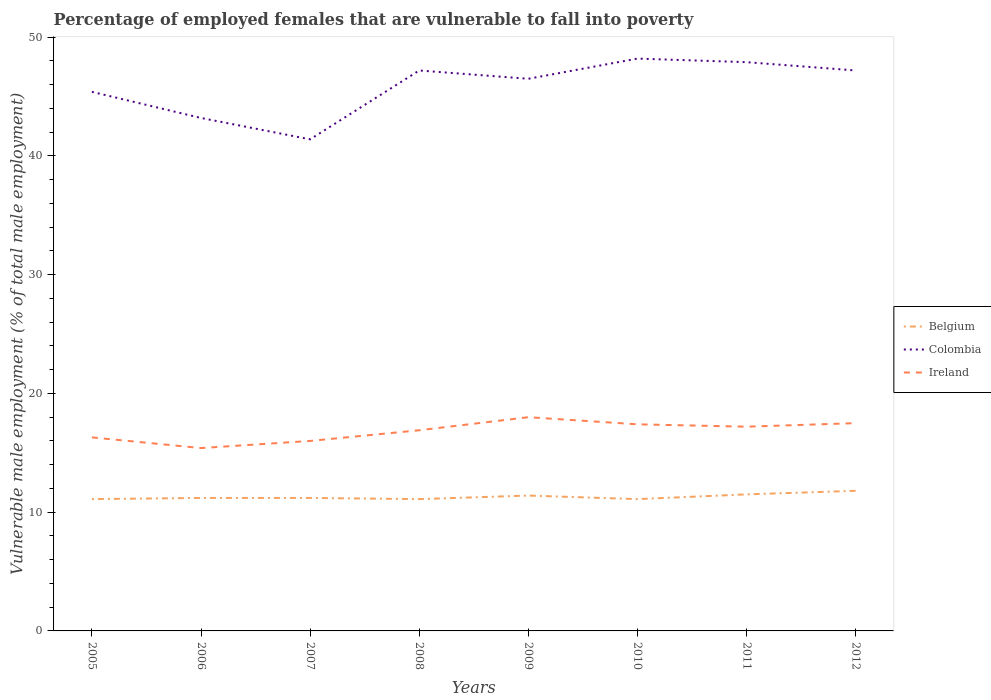Does the line corresponding to Colombia intersect with the line corresponding to Ireland?
Your response must be concise. No. Is the number of lines equal to the number of legend labels?
Keep it short and to the point. Yes. Across all years, what is the maximum percentage of employed females who are vulnerable to fall into poverty in Ireland?
Your answer should be compact. 15.4. In which year was the percentage of employed females who are vulnerable to fall into poverty in Belgium maximum?
Ensure brevity in your answer.  2005. What is the total percentage of employed females who are vulnerable to fall into poverty in Colombia in the graph?
Your response must be concise. -0.7. What is the difference between the highest and the second highest percentage of employed females who are vulnerable to fall into poverty in Colombia?
Provide a short and direct response. 6.8. What is the difference between the highest and the lowest percentage of employed females who are vulnerable to fall into poverty in Ireland?
Your answer should be compact. 5. How many years are there in the graph?
Offer a very short reply. 8. What is the difference between two consecutive major ticks on the Y-axis?
Provide a succinct answer. 10. Are the values on the major ticks of Y-axis written in scientific E-notation?
Keep it short and to the point. No. Where does the legend appear in the graph?
Provide a short and direct response. Center right. What is the title of the graph?
Your response must be concise. Percentage of employed females that are vulnerable to fall into poverty. Does "Russian Federation" appear as one of the legend labels in the graph?
Keep it short and to the point. No. What is the label or title of the X-axis?
Your answer should be very brief. Years. What is the label or title of the Y-axis?
Your answer should be very brief. Vulnerable male employment (% of total male employment). What is the Vulnerable male employment (% of total male employment) of Belgium in 2005?
Your response must be concise. 11.1. What is the Vulnerable male employment (% of total male employment) of Colombia in 2005?
Keep it short and to the point. 45.4. What is the Vulnerable male employment (% of total male employment) of Ireland in 2005?
Offer a very short reply. 16.3. What is the Vulnerable male employment (% of total male employment) of Belgium in 2006?
Offer a terse response. 11.2. What is the Vulnerable male employment (% of total male employment) of Colombia in 2006?
Your answer should be very brief. 43.2. What is the Vulnerable male employment (% of total male employment) in Ireland in 2006?
Offer a terse response. 15.4. What is the Vulnerable male employment (% of total male employment) in Belgium in 2007?
Your answer should be very brief. 11.2. What is the Vulnerable male employment (% of total male employment) of Colombia in 2007?
Your answer should be compact. 41.4. What is the Vulnerable male employment (% of total male employment) in Ireland in 2007?
Provide a short and direct response. 16. What is the Vulnerable male employment (% of total male employment) in Belgium in 2008?
Provide a short and direct response. 11.1. What is the Vulnerable male employment (% of total male employment) in Colombia in 2008?
Offer a terse response. 47.2. What is the Vulnerable male employment (% of total male employment) in Ireland in 2008?
Provide a succinct answer. 16.9. What is the Vulnerable male employment (% of total male employment) of Belgium in 2009?
Your answer should be very brief. 11.4. What is the Vulnerable male employment (% of total male employment) in Colombia in 2009?
Give a very brief answer. 46.5. What is the Vulnerable male employment (% of total male employment) of Belgium in 2010?
Ensure brevity in your answer.  11.1. What is the Vulnerable male employment (% of total male employment) of Colombia in 2010?
Keep it short and to the point. 48.2. What is the Vulnerable male employment (% of total male employment) of Ireland in 2010?
Provide a short and direct response. 17.4. What is the Vulnerable male employment (% of total male employment) of Belgium in 2011?
Make the answer very short. 11.5. What is the Vulnerable male employment (% of total male employment) of Colombia in 2011?
Your response must be concise. 47.9. What is the Vulnerable male employment (% of total male employment) of Ireland in 2011?
Provide a short and direct response. 17.2. What is the Vulnerable male employment (% of total male employment) in Belgium in 2012?
Provide a succinct answer. 11.8. What is the Vulnerable male employment (% of total male employment) of Colombia in 2012?
Provide a short and direct response. 47.2. What is the Vulnerable male employment (% of total male employment) of Ireland in 2012?
Your answer should be compact. 17.5. Across all years, what is the maximum Vulnerable male employment (% of total male employment) in Belgium?
Ensure brevity in your answer.  11.8. Across all years, what is the maximum Vulnerable male employment (% of total male employment) in Colombia?
Your answer should be compact. 48.2. Across all years, what is the maximum Vulnerable male employment (% of total male employment) in Ireland?
Provide a short and direct response. 18. Across all years, what is the minimum Vulnerable male employment (% of total male employment) in Belgium?
Your answer should be very brief. 11.1. Across all years, what is the minimum Vulnerable male employment (% of total male employment) of Colombia?
Offer a very short reply. 41.4. Across all years, what is the minimum Vulnerable male employment (% of total male employment) of Ireland?
Provide a succinct answer. 15.4. What is the total Vulnerable male employment (% of total male employment) in Belgium in the graph?
Give a very brief answer. 90.4. What is the total Vulnerable male employment (% of total male employment) of Colombia in the graph?
Give a very brief answer. 367. What is the total Vulnerable male employment (% of total male employment) of Ireland in the graph?
Your answer should be compact. 134.7. What is the difference between the Vulnerable male employment (% of total male employment) in Belgium in 2005 and that in 2006?
Provide a short and direct response. -0.1. What is the difference between the Vulnerable male employment (% of total male employment) in Colombia in 2005 and that in 2006?
Your answer should be very brief. 2.2. What is the difference between the Vulnerable male employment (% of total male employment) in Belgium in 2005 and that in 2007?
Offer a very short reply. -0.1. What is the difference between the Vulnerable male employment (% of total male employment) of Colombia in 2005 and that in 2007?
Keep it short and to the point. 4. What is the difference between the Vulnerable male employment (% of total male employment) of Belgium in 2005 and that in 2008?
Make the answer very short. 0. What is the difference between the Vulnerable male employment (% of total male employment) in Colombia in 2005 and that in 2008?
Offer a very short reply. -1.8. What is the difference between the Vulnerable male employment (% of total male employment) of Belgium in 2005 and that in 2009?
Offer a very short reply. -0.3. What is the difference between the Vulnerable male employment (% of total male employment) of Colombia in 2005 and that in 2009?
Your response must be concise. -1.1. What is the difference between the Vulnerable male employment (% of total male employment) in Colombia in 2005 and that in 2010?
Offer a terse response. -2.8. What is the difference between the Vulnerable male employment (% of total male employment) of Belgium in 2005 and that in 2011?
Keep it short and to the point. -0.4. What is the difference between the Vulnerable male employment (% of total male employment) of Colombia in 2005 and that in 2011?
Offer a terse response. -2.5. What is the difference between the Vulnerable male employment (% of total male employment) in Ireland in 2005 and that in 2011?
Your response must be concise. -0.9. What is the difference between the Vulnerable male employment (% of total male employment) in Ireland in 2005 and that in 2012?
Your answer should be compact. -1.2. What is the difference between the Vulnerable male employment (% of total male employment) of Belgium in 2006 and that in 2007?
Provide a short and direct response. 0. What is the difference between the Vulnerable male employment (% of total male employment) in Colombia in 2006 and that in 2007?
Your answer should be compact. 1.8. What is the difference between the Vulnerable male employment (% of total male employment) in Ireland in 2006 and that in 2007?
Your response must be concise. -0.6. What is the difference between the Vulnerable male employment (% of total male employment) of Colombia in 2006 and that in 2008?
Give a very brief answer. -4. What is the difference between the Vulnerable male employment (% of total male employment) in Ireland in 2006 and that in 2008?
Make the answer very short. -1.5. What is the difference between the Vulnerable male employment (% of total male employment) of Belgium in 2006 and that in 2009?
Keep it short and to the point. -0.2. What is the difference between the Vulnerable male employment (% of total male employment) in Colombia in 2006 and that in 2009?
Ensure brevity in your answer.  -3.3. What is the difference between the Vulnerable male employment (% of total male employment) of Belgium in 2006 and that in 2010?
Provide a succinct answer. 0.1. What is the difference between the Vulnerable male employment (% of total male employment) of Ireland in 2006 and that in 2011?
Your response must be concise. -1.8. What is the difference between the Vulnerable male employment (% of total male employment) in Colombia in 2006 and that in 2012?
Ensure brevity in your answer.  -4. What is the difference between the Vulnerable male employment (% of total male employment) in Ireland in 2006 and that in 2012?
Give a very brief answer. -2.1. What is the difference between the Vulnerable male employment (% of total male employment) of Belgium in 2007 and that in 2008?
Provide a short and direct response. 0.1. What is the difference between the Vulnerable male employment (% of total male employment) of Ireland in 2007 and that in 2008?
Your answer should be compact. -0.9. What is the difference between the Vulnerable male employment (% of total male employment) of Belgium in 2007 and that in 2009?
Your response must be concise. -0.2. What is the difference between the Vulnerable male employment (% of total male employment) in Colombia in 2007 and that in 2010?
Make the answer very short. -6.8. What is the difference between the Vulnerable male employment (% of total male employment) of Ireland in 2007 and that in 2010?
Provide a succinct answer. -1.4. What is the difference between the Vulnerable male employment (% of total male employment) of Belgium in 2007 and that in 2011?
Keep it short and to the point. -0.3. What is the difference between the Vulnerable male employment (% of total male employment) of Colombia in 2007 and that in 2011?
Make the answer very short. -6.5. What is the difference between the Vulnerable male employment (% of total male employment) in Belgium in 2007 and that in 2012?
Your response must be concise. -0.6. What is the difference between the Vulnerable male employment (% of total male employment) of Ireland in 2007 and that in 2012?
Your answer should be compact. -1.5. What is the difference between the Vulnerable male employment (% of total male employment) in Belgium in 2008 and that in 2009?
Provide a succinct answer. -0.3. What is the difference between the Vulnerable male employment (% of total male employment) in Ireland in 2008 and that in 2010?
Make the answer very short. -0.5. What is the difference between the Vulnerable male employment (% of total male employment) of Belgium in 2008 and that in 2011?
Ensure brevity in your answer.  -0.4. What is the difference between the Vulnerable male employment (% of total male employment) of Belgium in 2008 and that in 2012?
Give a very brief answer. -0.7. What is the difference between the Vulnerable male employment (% of total male employment) in Ireland in 2008 and that in 2012?
Offer a terse response. -0.6. What is the difference between the Vulnerable male employment (% of total male employment) of Belgium in 2009 and that in 2010?
Provide a succinct answer. 0.3. What is the difference between the Vulnerable male employment (% of total male employment) in Colombia in 2009 and that in 2010?
Your answer should be very brief. -1.7. What is the difference between the Vulnerable male employment (% of total male employment) of Belgium in 2009 and that in 2011?
Provide a short and direct response. -0.1. What is the difference between the Vulnerable male employment (% of total male employment) of Belgium in 2009 and that in 2012?
Keep it short and to the point. -0.4. What is the difference between the Vulnerable male employment (% of total male employment) of Colombia in 2009 and that in 2012?
Your answer should be very brief. -0.7. What is the difference between the Vulnerable male employment (% of total male employment) of Colombia in 2010 and that in 2011?
Ensure brevity in your answer.  0.3. What is the difference between the Vulnerable male employment (% of total male employment) in Colombia in 2010 and that in 2012?
Your answer should be compact. 1. What is the difference between the Vulnerable male employment (% of total male employment) of Ireland in 2010 and that in 2012?
Your answer should be compact. -0.1. What is the difference between the Vulnerable male employment (% of total male employment) of Ireland in 2011 and that in 2012?
Offer a terse response. -0.3. What is the difference between the Vulnerable male employment (% of total male employment) of Belgium in 2005 and the Vulnerable male employment (% of total male employment) of Colombia in 2006?
Offer a very short reply. -32.1. What is the difference between the Vulnerable male employment (% of total male employment) of Belgium in 2005 and the Vulnerable male employment (% of total male employment) of Colombia in 2007?
Give a very brief answer. -30.3. What is the difference between the Vulnerable male employment (% of total male employment) in Belgium in 2005 and the Vulnerable male employment (% of total male employment) in Ireland in 2007?
Give a very brief answer. -4.9. What is the difference between the Vulnerable male employment (% of total male employment) of Colombia in 2005 and the Vulnerable male employment (% of total male employment) of Ireland in 2007?
Your answer should be very brief. 29.4. What is the difference between the Vulnerable male employment (% of total male employment) in Belgium in 2005 and the Vulnerable male employment (% of total male employment) in Colombia in 2008?
Keep it short and to the point. -36.1. What is the difference between the Vulnerable male employment (% of total male employment) of Belgium in 2005 and the Vulnerable male employment (% of total male employment) of Ireland in 2008?
Your response must be concise. -5.8. What is the difference between the Vulnerable male employment (% of total male employment) in Colombia in 2005 and the Vulnerable male employment (% of total male employment) in Ireland in 2008?
Give a very brief answer. 28.5. What is the difference between the Vulnerable male employment (% of total male employment) of Belgium in 2005 and the Vulnerable male employment (% of total male employment) of Colombia in 2009?
Offer a very short reply. -35.4. What is the difference between the Vulnerable male employment (% of total male employment) in Belgium in 2005 and the Vulnerable male employment (% of total male employment) in Ireland in 2009?
Give a very brief answer. -6.9. What is the difference between the Vulnerable male employment (% of total male employment) in Colombia in 2005 and the Vulnerable male employment (% of total male employment) in Ireland in 2009?
Provide a short and direct response. 27.4. What is the difference between the Vulnerable male employment (% of total male employment) in Belgium in 2005 and the Vulnerable male employment (% of total male employment) in Colombia in 2010?
Provide a succinct answer. -37.1. What is the difference between the Vulnerable male employment (% of total male employment) in Belgium in 2005 and the Vulnerable male employment (% of total male employment) in Ireland in 2010?
Ensure brevity in your answer.  -6.3. What is the difference between the Vulnerable male employment (% of total male employment) in Belgium in 2005 and the Vulnerable male employment (% of total male employment) in Colombia in 2011?
Your response must be concise. -36.8. What is the difference between the Vulnerable male employment (% of total male employment) of Colombia in 2005 and the Vulnerable male employment (% of total male employment) of Ireland in 2011?
Provide a succinct answer. 28.2. What is the difference between the Vulnerable male employment (% of total male employment) of Belgium in 2005 and the Vulnerable male employment (% of total male employment) of Colombia in 2012?
Keep it short and to the point. -36.1. What is the difference between the Vulnerable male employment (% of total male employment) of Belgium in 2005 and the Vulnerable male employment (% of total male employment) of Ireland in 2012?
Your answer should be compact. -6.4. What is the difference between the Vulnerable male employment (% of total male employment) in Colombia in 2005 and the Vulnerable male employment (% of total male employment) in Ireland in 2012?
Your answer should be very brief. 27.9. What is the difference between the Vulnerable male employment (% of total male employment) of Belgium in 2006 and the Vulnerable male employment (% of total male employment) of Colombia in 2007?
Keep it short and to the point. -30.2. What is the difference between the Vulnerable male employment (% of total male employment) in Belgium in 2006 and the Vulnerable male employment (% of total male employment) in Ireland in 2007?
Provide a short and direct response. -4.8. What is the difference between the Vulnerable male employment (% of total male employment) of Colombia in 2006 and the Vulnerable male employment (% of total male employment) of Ireland in 2007?
Your response must be concise. 27.2. What is the difference between the Vulnerable male employment (% of total male employment) in Belgium in 2006 and the Vulnerable male employment (% of total male employment) in Colombia in 2008?
Your answer should be very brief. -36. What is the difference between the Vulnerable male employment (% of total male employment) of Colombia in 2006 and the Vulnerable male employment (% of total male employment) of Ireland in 2008?
Your answer should be very brief. 26.3. What is the difference between the Vulnerable male employment (% of total male employment) of Belgium in 2006 and the Vulnerable male employment (% of total male employment) of Colombia in 2009?
Offer a terse response. -35.3. What is the difference between the Vulnerable male employment (% of total male employment) in Belgium in 2006 and the Vulnerable male employment (% of total male employment) in Ireland in 2009?
Your answer should be compact. -6.8. What is the difference between the Vulnerable male employment (% of total male employment) of Colombia in 2006 and the Vulnerable male employment (% of total male employment) of Ireland in 2009?
Your answer should be very brief. 25.2. What is the difference between the Vulnerable male employment (% of total male employment) in Belgium in 2006 and the Vulnerable male employment (% of total male employment) in Colombia in 2010?
Offer a very short reply. -37. What is the difference between the Vulnerable male employment (% of total male employment) in Colombia in 2006 and the Vulnerable male employment (% of total male employment) in Ireland in 2010?
Your response must be concise. 25.8. What is the difference between the Vulnerable male employment (% of total male employment) of Belgium in 2006 and the Vulnerable male employment (% of total male employment) of Colombia in 2011?
Provide a succinct answer. -36.7. What is the difference between the Vulnerable male employment (% of total male employment) in Belgium in 2006 and the Vulnerable male employment (% of total male employment) in Colombia in 2012?
Offer a terse response. -36. What is the difference between the Vulnerable male employment (% of total male employment) of Colombia in 2006 and the Vulnerable male employment (% of total male employment) of Ireland in 2012?
Give a very brief answer. 25.7. What is the difference between the Vulnerable male employment (% of total male employment) of Belgium in 2007 and the Vulnerable male employment (% of total male employment) of Colombia in 2008?
Offer a very short reply. -36. What is the difference between the Vulnerable male employment (% of total male employment) in Belgium in 2007 and the Vulnerable male employment (% of total male employment) in Ireland in 2008?
Your response must be concise. -5.7. What is the difference between the Vulnerable male employment (% of total male employment) in Colombia in 2007 and the Vulnerable male employment (% of total male employment) in Ireland in 2008?
Make the answer very short. 24.5. What is the difference between the Vulnerable male employment (% of total male employment) of Belgium in 2007 and the Vulnerable male employment (% of total male employment) of Colombia in 2009?
Provide a succinct answer. -35.3. What is the difference between the Vulnerable male employment (% of total male employment) of Colombia in 2007 and the Vulnerable male employment (% of total male employment) of Ireland in 2009?
Your answer should be very brief. 23.4. What is the difference between the Vulnerable male employment (% of total male employment) of Belgium in 2007 and the Vulnerable male employment (% of total male employment) of Colombia in 2010?
Your response must be concise. -37. What is the difference between the Vulnerable male employment (% of total male employment) in Belgium in 2007 and the Vulnerable male employment (% of total male employment) in Ireland in 2010?
Provide a short and direct response. -6.2. What is the difference between the Vulnerable male employment (% of total male employment) of Colombia in 2007 and the Vulnerable male employment (% of total male employment) of Ireland in 2010?
Make the answer very short. 24. What is the difference between the Vulnerable male employment (% of total male employment) of Belgium in 2007 and the Vulnerable male employment (% of total male employment) of Colombia in 2011?
Give a very brief answer. -36.7. What is the difference between the Vulnerable male employment (% of total male employment) in Belgium in 2007 and the Vulnerable male employment (% of total male employment) in Ireland in 2011?
Keep it short and to the point. -6. What is the difference between the Vulnerable male employment (% of total male employment) of Colombia in 2007 and the Vulnerable male employment (% of total male employment) of Ireland in 2011?
Offer a terse response. 24.2. What is the difference between the Vulnerable male employment (% of total male employment) of Belgium in 2007 and the Vulnerable male employment (% of total male employment) of Colombia in 2012?
Give a very brief answer. -36. What is the difference between the Vulnerable male employment (% of total male employment) in Belgium in 2007 and the Vulnerable male employment (% of total male employment) in Ireland in 2012?
Provide a succinct answer. -6.3. What is the difference between the Vulnerable male employment (% of total male employment) of Colombia in 2007 and the Vulnerable male employment (% of total male employment) of Ireland in 2012?
Your answer should be very brief. 23.9. What is the difference between the Vulnerable male employment (% of total male employment) of Belgium in 2008 and the Vulnerable male employment (% of total male employment) of Colombia in 2009?
Make the answer very short. -35.4. What is the difference between the Vulnerable male employment (% of total male employment) in Colombia in 2008 and the Vulnerable male employment (% of total male employment) in Ireland in 2009?
Keep it short and to the point. 29.2. What is the difference between the Vulnerable male employment (% of total male employment) of Belgium in 2008 and the Vulnerable male employment (% of total male employment) of Colombia in 2010?
Your answer should be compact. -37.1. What is the difference between the Vulnerable male employment (% of total male employment) of Belgium in 2008 and the Vulnerable male employment (% of total male employment) of Ireland in 2010?
Your response must be concise. -6.3. What is the difference between the Vulnerable male employment (% of total male employment) in Colombia in 2008 and the Vulnerable male employment (% of total male employment) in Ireland in 2010?
Give a very brief answer. 29.8. What is the difference between the Vulnerable male employment (% of total male employment) in Belgium in 2008 and the Vulnerable male employment (% of total male employment) in Colombia in 2011?
Provide a succinct answer. -36.8. What is the difference between the Vulnerable male employment (% of total male employment) of Colombia in 2008 and the Vulnerable male employment (% of total male employment) of Ireland in 2011?
Your answer should be very brief. 30. What is the difference between the Vulnerable male employment (% of total male employment) in Belgium in 2008 and the Vulnerable male employment (% of total male employment) in Colombia in 2012?
Your response must be concise. -36.1. What is the difference between the Vulnerable male employment (% of total male employment) in Colombia in 2008 and the Vulnerable male employment (% of total male employment) in Ireland in 2012?
Offer a terse response. 29.7. What is the difference between the Vulnerable male employment (% of total male employment) in Belgium in 2009 and the Vulnerable male employment (% of total male employment) in Colombia in 2010?
Give a very brief answer. -36.8. What is the difference between the Vulnerable male employment (% of total male employment) of Belgium in 2009 and the Vulnerable male employment (% of total male employment) of Ireland in 2010?
Make the answer very short. -6. What is the difference between the Vulnerable male employment (% of total male employment) in Colombia in 2009 and the Vulnerable male employment (% of total male employment) in Ireland in 2010?
Offer a very short reply. 29.1. What is the difference between the Vulnerable male employment (% of total male employment) in Belgium in 2009 and the Vulnerable male employment (% of total male employment) in Colombia in 2011?
Your response must be concise. -36.5. What is the difference between the Vulnerable male employment (% of total male employment) in Colombia in 2009 and the Vulnerable male employment (% of total male employment) in Ireland in 2011?
Your answer should be compact. 29.3. What is the difference between the Vulnerable male employment (% of total male employment) of Belgium in 2009 and the Vulnerable male employment (% of total male employment) of Colombia in 2012?
Provide a short and direct response. -35.8. What is the difference between the Vulnerable male employment (% of total male employment) of Belgium in 2009 and the Vulnerable male employment (% of total male employment) of Ireland in 2012?
Your response must be concise. -6.1. What is the difference between the Vulnerable male employment (% of total male employment) of Colombia in 2009 and the Vulnerable male employment (% of total male employment) of Ireland in 2012?
Your response must be concise. 29. What is the difference between the Vulnerable male employment (% of total male employment) of Belgium in 2010 and the Vulnerable male employment (% of total male employment) of Colombia in 2011?
Your response must be concise. -36.8. What is the difference between the Vulnerable male employment (% of total male employment) of Colombia in 2010 and the Vulnerable male employment (% of total male employment) of Ireland in 2011?
Your answer should be very brief. 31. What is the difference between the Vulnerable male employment (% of total male employment) of Belgium in 2010 and the Vulnerable male employment (% of total male employment) of Colombia in 2012?
Make the answer very short. -36.1. What is the difference between the Vulnerable male employment (% of total male employment) of Belgium in 2010 and the Vulnerable male employment (% of total male employment) of Ireland in 2012?
Provide a short and direct response. -6.4. What is the difference between the Vulnerable male employment (% of total male employment) in Colombia in 2010 and the Vulnerable male employment (% of total male employment) in Ireland in 2012?
Offer a very short reply. 30.7. What is the difference between the Vulnerable male employment (% of total male employment) in Belgium in 2011 and the Vulnerable male employment (% of total male employment) in Colombia in 2012?
Provide a short and direct response. -35.7. What is the difference between the Vulnerable male employment (% of total male employment) of Colombia in 2011 and the Vulnerable male employment (% of total male employment) of Ireland in 2012?
Offer a terse response. 30.4. What is the average Vulnerable male employment (% of total male employment) in Belgium per year?
Give a very brief answer. 11.3. What is the average Vulnerable male employment (% of total male employment) of Colombia per year?
Provide a short and direct response. 45.88. What is the average Vulnerable male employment (% of total male employment) of Ireland per year?
Give a very brief answer. 16.84. In the year 2005, what is the difference between the Vulnerable male employment (% of total male employment) of Belgium and Vulnerable male employment (% of total male employment) of Colombia?
Keep it short and to the point. -34.3. In the year 2005, what is the difference between the Vulnerable male employment (% of total male employment) in Belgium and Vulnerable male employment (% of total male employment) in Ireland?
Give a very brief answer. -5.2. In the year 2005, what is the difference between the Vulnerable male employment (% of total male employment) in Colombia and Vulnerable male employment (% of total male employment) in Ireland?
Ensure brevity in your answer.  29.1. In the year 2006, what is the difference between the Vulnerable male employment (% of total male employment) of Belgium and Vulnerable male employment (% of total male employment) of Colombia?
Provide a succinct answer. -32. In the year 2006, what is the difference between the Vulnerable male employment (% of total male employment) in Colombia and Vulnerable male employment (% of total male employment) in Ireland?
Provide a short and direct response. 27.8. In the year 2007, what is the difference between the Vulnerable male employment (% of total male employment) in Belgium and Vulnerable male employment (% of total male employment) in Colombia?
Your answer should be compact. -30.2. In the year 2007, what is the difference between the Vulnerable male employment (% of total male employment) of Colombia and Vulnerable male employment (% of total male employment) of Ireland?
Your response must be concise. 25.4. In the year 2008, what is the difference between the Vulnerable male employment (% of total male employment) of Belgium and Vulnerable male employment (% of total male employment) of Colombia?
Your response must be concise. -36.1. In the year 2008, what is the difference between the Vulnerable male employment (% of total male employment) of Belgium and Vulnerable male employment (% of total male employment) of Ireland?
Make the answer very short. -5.8. In the year 2008, what is the difference between the Vulnerable male employment (% of total male employment) of Colombia and Vulnerable male employment (% of total male employment) of Ireland?
Make the answer very short. 30.3. In the year 2009, what is the difference between the Vulnerable male employment (% of total male employment) in Belgium and Vulnerable male employment (% of total male employment) in Colombia?
Ensure brevity in your answer.  -35.1. In the year 2009, what is the difference between the Vulnerable male employment (% of total male employment) of Colombia and Vulnerable male employment (% of total male employment) of Ireland?
Provide a short and direct response. 28.5. In the year 2010, what is the difference between the Vulnerable male employment (% of total male employment) of Belgium and Vulnerable male employment (% of total male employment) of Colombia?
Your answer should be compact. -37.1. In the year 2010, what is the difference between the Vulnerable male employment (% of total male employment) in Belgium and Vulnerable male employment (% of total male employment) in Ireland?
Provide a succinct answer. -6.3. In the year 2010, what is the difference between the Vulnerable male employment (% of total male employment) of Colombia and Vulnerable male employment (% of total male employment) of Ireland?
Your answer should be very brief. 30.8. In the year 2011, what is the difference between the Vulnerable male employment (% of total male employment) in Belgium and Vulnerable male employment (% of total male employment) in Colombia?
Your answer should be very brief. -36.4. In the year 2011, what is the difference between the Vulnerable male employment (% of total male employment) of Belgium and Vulnerable male employment (% of total male employment) of Ireland?
Offer a very short reply. -5.7. In the year 2011, what is the difference between the Vulnerable male employment (% of total male employment) of Colombia and Vulnerable male employment (% of total male employment) of Ireland?
Keep it short and to the point. 30.7. In the year 2012, what is the difference between the Vulnerable male employment (% of total male employment) in Belgium and Vulnerable male employment (% of total male employment) in Colombia?
Your answer should be compact. -35.4. In the year 2012, what is the difference between the Vulnerable male employment (% of total male employment) in Colombia and Vulnerable male employment (% of total male employment) in Ireland?
Keep it short and to the point. 29.7. What is the ratio of the Vulnerable male employment (% of total male employment) of Colombia in 2005 to that in 2006?
Provide a short and direct response. 1.05. What is the ratio of the Vulnerable male employment (% of total male employment) in Ireland in 2005 to that in 2006?
Make the answer very short. 1.06. What is the ratio of the Vulnerable male employment (% of total male employment) in Belgium in 2005 to that in 2007?
Offer a very short reply. 0.99. What is the ratio of the Vulnerable male employment (% of total male employment) in Colombia in 2005 to that in 2007?
Your answer should be very brief. 1.1. What is the ratio of the Vulnerable male employment (% of total male employment) in Ireland in 2005 to that in 2007?
Your response must be concise. 1.02. What is the ratio of the Vulnerable male employment (% of total male employment) in Belgium in 2005 to that in 2008?
Provide a succinct answer. 1. What is the ratio of the Vulnerable male employment (% of total male employment) of Colombia in 2005 to that in 2008?
Your answer should be compact. 0.96. What is the ratio of the Vulnerable male employment (% of total male employment) of Ireland in 2005 to that in 2008?
Offer a terse response. 0.96. What is the ratio of the Vulnerable male employment (% of total male employment) of Belgium in 2005 to that in 2009?
Offer a very short reply. 0.97. What is the ratio of the Vulnerable male employment (% of total male employment) in Colombia in 2005 to that in 2009?
Make the answer very short. 0.98. What is the ratio of the Vulnerable male employment (% of total male employment) in Ireland in 2005 to that in 2009?
Offer a terse response. 0.91. What is the ratio of the Vulnerable male employment (% of total male employment) in Belgium in 2005 to that in 2010?
Provide a short and direct response. 1. What is the ratio of the Vulnerable male employment (% of total male employment) of Colombia in 2005 to that in 2010?
Your response must be concise. 0.94. What is the ratio of the Vulnerable male employment (% of total male employment) of Ireland in 2005 to that in 2010?
Your answer should be very brief. 0.94. What is the ratio of the Vulnerable male employment (% of total male employment) in Belgium in 2005 to that in 2011?
Make the answer very short. 0.97. What is the ratio of the Vulnerable male employment (% of total male employment) of Colombia in 2005 to that in 2011?
Give a very brief answer. 0.95. What is the ratio of the Vulnerable male employment (% of total male employment) in Ireland in 2005 to that in 2011?
Offer a terse response. 0.95. What is the ratio of the Vulnerable male employment (% of total male employment) of Belgium in 2005 to that in 2012?
Your answer should be compact. 0.94. What is the ratio of the Vulnerable male employment (% of total male employment) of Colombia in 2005 to that in 2012?
Your response must be concise. 0.96. What is the ratio of the Vulnerable male employment (% of total male employment) in Ireland in 2005 to that in 2012?
Provide a short and direct response. 0.93. What is the ratio of the Vulnerable male employment (% of total male employment) of Colombia in 2006 to that in 2007?
Make the answer very short. 1.04. What is the ratio of the Vulnerable male employment (% of total male employment) in Ireland in 2006 to that in 2007?
Ensure brevity in your answer.  0.96. What is the ratio of the Vulnerable male employment (% of total male employment) in Colombia in 2006 to that in 2008?
Provide a succinct answer. 0.92. What is the ratio of the Vulnerable male employment (% of total male employment) in Ireland in 2006 to that in 2008?
Give a very brief answer. 0.91. What is the ratio of the Vulnerable male employment (% of total male employment) of Belgium in 2006 to that in 2009?
Your response must be concise. 0.98. What is the ratio of the Vulnerable male employment (% of total male employment) of Colombia in 2006 to that in 2009?
Ensure brevity in your answer.  0.93. What is the ratio of the Vulnerable male employment (% of total male employment) of Ireland in 2006 to that in 2009?
Provide a short and direct response. 0.86. What is the ratio of the Vulnerable male employment (% of total male employment) of Belgium in 2006 to that in 2010?
Make the answer very short. 1.01. What is the ratio of the Vulnerable male employment (% of total male employment) of Colombia in 2006 to that in 2010?
Keep it short and to the point. 0.9. What is the ratio of the Vulnerable male employment (% of total male employment) of Ireland in 2006 to that in 2010?
Your response must be concise. 0.89. What is the ratio of the Vulnerable male employment (% of total male employment) in Belgium in 2006 to that in 2011?
Provide a short and direct response. 0.97. What is the ratio of the Vulnerable male employment (% of total male employment) of Colombia in 2006 to that in 2011?
Provide a succinct answer. 0.9. What is the ratio of the Vulnerable male employment (% of total male employment) in Ireland in 2006 to that in 2011?
Your answer should be very brief. 0.9. What is the ratio of the Vulnerable male employment (% of total male employment) in Belgium in 2006 to that in 2012?
Your response must be concise. 0.95. What is the ratio of the Vulnerable male employment (% of total male employment) of Colombia in 2006 to that in 2012?
Provide a short and direct response. 0.92. What is the ratio of the Vulnerable male employment (% of total male employment) in Belgium in 2007 to that in 2008?
Ensure brevity in your answer.  1.01. What is the ratio of the Vulnerable male employment (% of total male employment) in Colombia in 2007 to that in 2008?
Make the answer very short. 0.88. What is the ratio of the Vulnerable male employment (% of total male employment) of Ireland in 2007 to that in 2008?
Give a very brief answer. 0.95. What is the ratio of the Vulnerable male employment (% of total male employment) in Belgium in 2007 to that in 2009?
Give a very brief answer. 0.98. What is the ratio of the Vulnerable male employment (% of total male employment) in Colombia in 2007 to that in 2009?
Ensure brevity in your answer.  0.89. What is the ratio of the Vulnerable male employment (% of total male employment) in Belgium in 2007 to that in 2010?
Provide a short and direct response. 1.01. What is the ratio of the Vulnerable male employment (% of total male employment) of Colombia in 2007 to that in 2010?
Give a very brief answer. 0.86. What is the ratio of the Vulnerable male employment (% of total male employment) of Ireland in 2007 to that in 2010?
Keep it short and to the point. 0.92. What is the ratio of the Vulnerable male employment (% of total male employment) of Belgium in 2007 to that in 2011?
Keep it short and to the point. 0.97. What is the ratio of the Vulnerable male employment (% of total male employment) of Colombia in 2007 to that in 2011?
Give a very brief answer. 0.86. What is the ratio of the Vulnerable male employment (% of total male employment) in Ireland in 2007 to that in 2011?
Your answer should be very brief. 0.93. What is the ratio of the Vulnerable male employment (% of total male employment) of Belgium in 2007 to that in 2012?
Your answer should be very brief. 0.95. What is the ratio of the Vulnerable male employment (% of total male employment) of Colombia in 2007 to that in 2012?
Your answer should be very brief. 0.88. What is the ratio of the Vulnerable male employment (% of total male employment) of Ireland in 2007 to that in 2012?
Your response must be concise. 0.91. What is the ratio of the Vulnerable male employment (% of total male employment) of Belgium in 2008 to that in 2009?
Your response must be concise. 0.97. What is the ratio of the Vulnerable male employment (% of total male employment) in Colombia in 2008 to that in 2009?
Offer a very short reply. 1.02. What is the ratio of the Vulnerable male employment (% of total male employment) in Ireland in 2008 to that in 2009?
Provide a short and direct response. 0.94. What is the ratio of the Vulnerable male employment (% of total male employment) of Colombia in 2008 to that in 2010?
Offer a terse response. 0.98. What is the ratio of the Vulnerable male employment (% of total male employment) of Ireland in 2008 to that in 2010?
Your response must be concise. 0.97. What is the ratio of the Vulnerable male employment (% of total male employment) in Belgium in 2008 to that in 2011?
Your answer should be very brief. 0.97. What is the ratio of the Vulnerable male employment (% of total male employment) of Colombia in 2008 to that in 2011?
Offer a very short reply. 0.99. What is the ratio of the Vulnerable male employment (% of total male employment) in Ireland in 2008 to that in 2011?
Make the answer very short. 0.98. What is the ratio of the Vulnerable male employment (% of total male employment) of Belgium in 2008 to that in 2012?
Offer a very short reply. 0.94. What is the ratio of the Vulnerable male employment (% of total male employment) in Ireland in 2008 to that in 2012?
Keep it short and to the point. 0.97. What is the ratio of the Vulnerable male employment (% of total male employment) of Belgium in 2009 to that in 2010?
Your answer should be very brief. 1.03. What is the ratio of the Vulnerable male employment (% of total male employment) of Colombia in 2009 to that in 2010?
Provide a short and direct response. 0.96. What is the ratio of the Vulnerable male employment (% of total male employment) of Ireland in 2009 to that in 2010?
Your answer should be compact. 1.03. What is the ratio of the Vulnerable male employment (% of total male employment) in Belgium in 2009 to that in 2011?
Ensure brevity in your answer.  0.99. What is the ratio of the Vulnerable male employment (% of total male employment) in Colombia in 2009 to that in 2011?
Make the answer very short. 0.97. What is the ratio of the Vulnerable male employment (% of total male employment) in Ireland in 2009 to that in 2011?
Offer a terse response. 1.05. What is the ratio of the Vulnerable male employment (% of total male employment) of Belgium in 2009 to that in 2012?
Offer a very short reply. 0.97. What is the ratio of the Vulnerable male employment (% of total male employment) in Colombia in 2009 to that in 2012?
Keep it short and to the point. 0.99. What is the ratio of the Vulnerable male employment (% of total male employment) of Ireland in 2009 to that in 2012?
Provide a short and direct response. 1.03. What is the ratio of the Vulnerable male employment (% of total male employment) in Belgium in 2010 to that in 2011?
Give a very brief answer. 0.97. What is the ratio of the Vulnerable male employment (% of total male employment) in Colombia in 2010 to that in 2011?
Make the answer very short. 1.01. What is the ratio of the Vulnerable male employment (% of total male employment) in Ireland in 2010 to that in 2011?
Your answer should be compact. 1.01. What is the ratio of the Vulnerable male employment (% of total male employment) of Belgium in 2010 to that in 2012?
Your answer should be very brief. 0.94. What is the ratio of the Vulnerable male employment (% of total male employment) in Colombia in 2010 to that in 2012?
Your response must be concise. 1.02. What is the ratio of the Vulnerable male employment (% of total male employment) in Ireland in 2010 to that in 2012?
Keep it short and to the point. 0.99. What is the ratio of the Vulnerable male employment (% of total male employment) of Belgium in 2011 to that in 2012?
Your response must be concise. 0.97. What is the ratio of the Vulnerable male employment (% of total male employment) of Colombia in 2011 to that in 2012?
Keep it short and to the point. 1.01. What is the ratio of the Vulnerable male employment (% of total male employment) in Ireland in 2011 to that in 2012?
Provide a short and direct response. 0.98. What is the difference between the highest and the lowest Vulnerable male employment (% of total male employment) of Colombia?
Offer a very short reply. 6.8. 